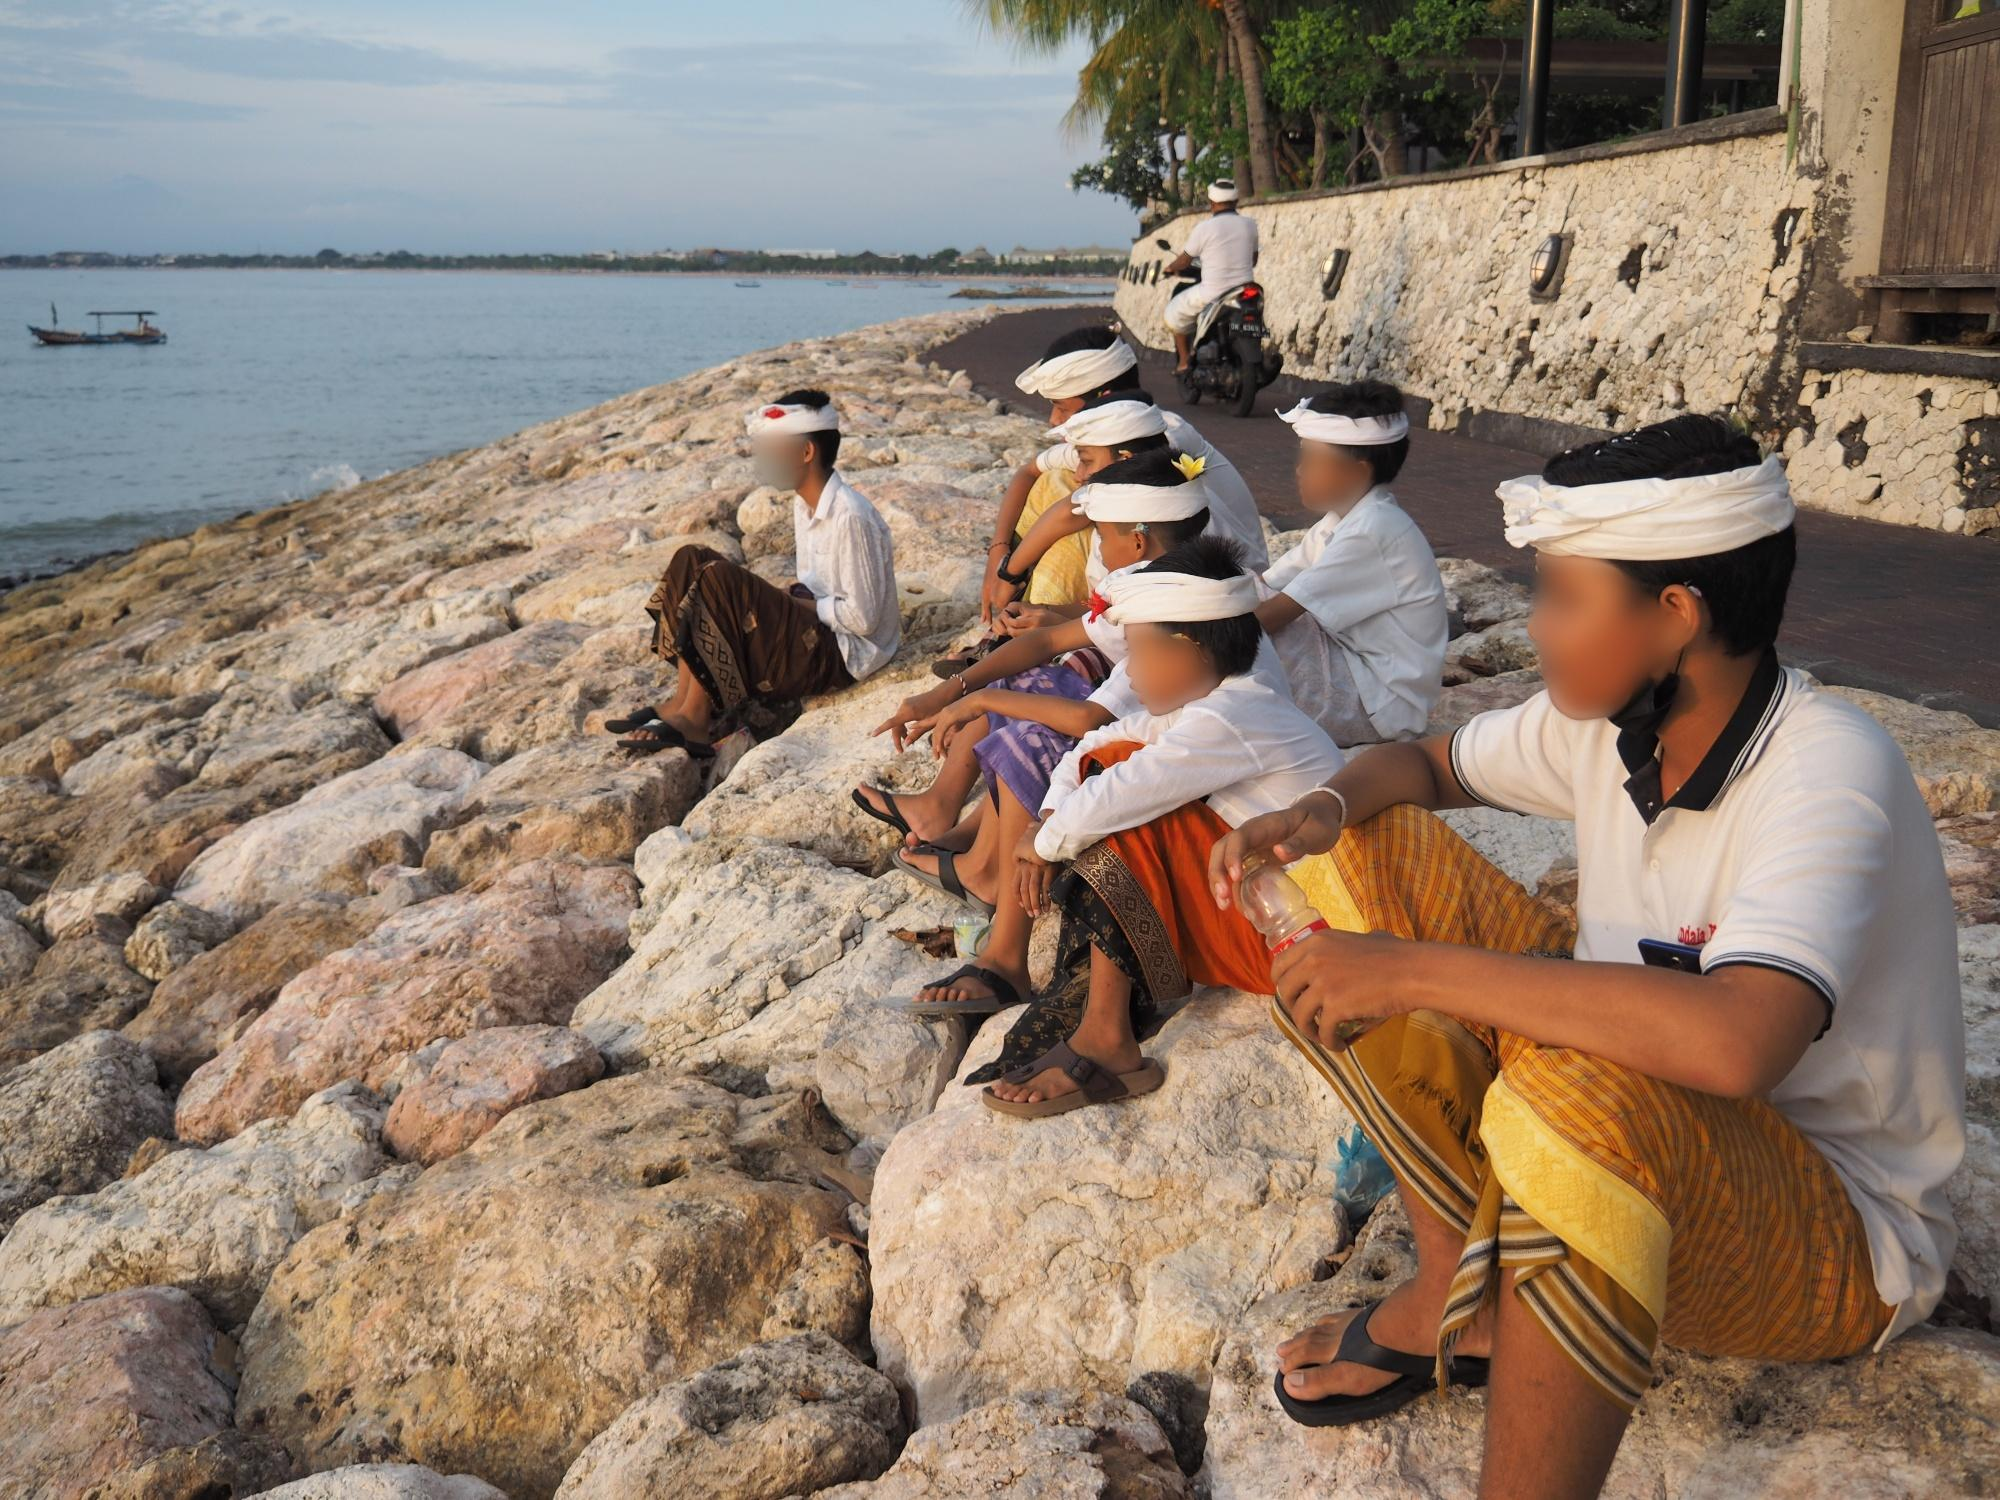What are the key elements in this picture? The image showcases a serene coastal scene where a group of individuals, dressed in vibrant traditional Balinese attire, are seated on a rocky shore. Each person is wearing a distinct headpiece, which is an integral part of Balinese traditional dress. The contrast between their colorful clothing and the natural textures of the rocky shoreline creates a striking visual effect. In the background, the calm ocean waters stretch out to the horizon, adding to the tranquil ambiance of the photograph. The photograph is captured from a low angle, emphasizing the individuals and their attire, while also allowing the vast ocean and the distant horizon to be visible. This combination of cultural elements and natural beauty contributes to the overall peaceful and picturesque atmosphere of the image. 